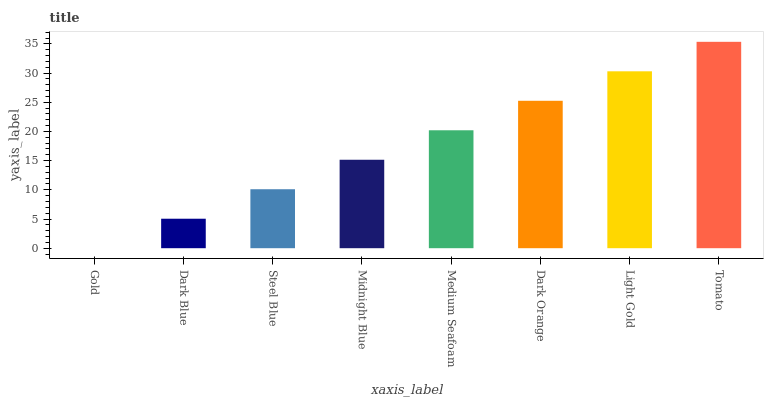Is Gold the minimum?
Answer yes or no. Yes. Is Tomato the maximum?
Answer yes or no. Yes. Is Dark Blue the minimum?
Answer yes or no. No. Is Dark Blue the maximum?
Answer yes or no. No. Is Dark Blue greater than Gold?
Answer yes or no. Yes. Is Gold less than Dark Blue?
Answer yes or no. Yes. Is Gold greater than Dark Blue?
Answer yes or no. No. Is Dark Blue less than Gold?
Answer yes or no. No. Is Medium Seafoam the high median?
Answer yes or no. Yes. Is Midnight Blue the low median?
Answer yes or no. Yes. Is Gold the high median?
Answer yes or no. No. Is Dark Orange the low median?
Answer yes or no. No. 